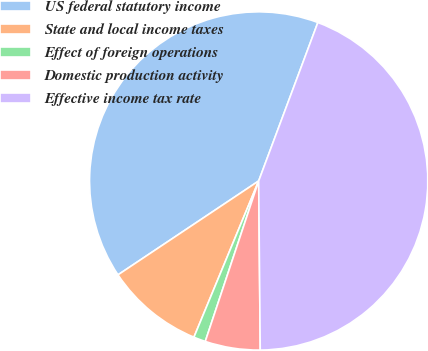<chart> <loc_0><loc_0><loc_500><loc_500><pie_chart><fcel>US federal statutory income<fcel>State and local income taxes<fcel>Effect of foreign operations<fcel>Domestic production activity<fcel>Effective income tax rate<nl><fcel>40.05%<fcel>9.38%<fcel>1.14%<fcel>5.26%<fcel>44.16%<nl></chart> 